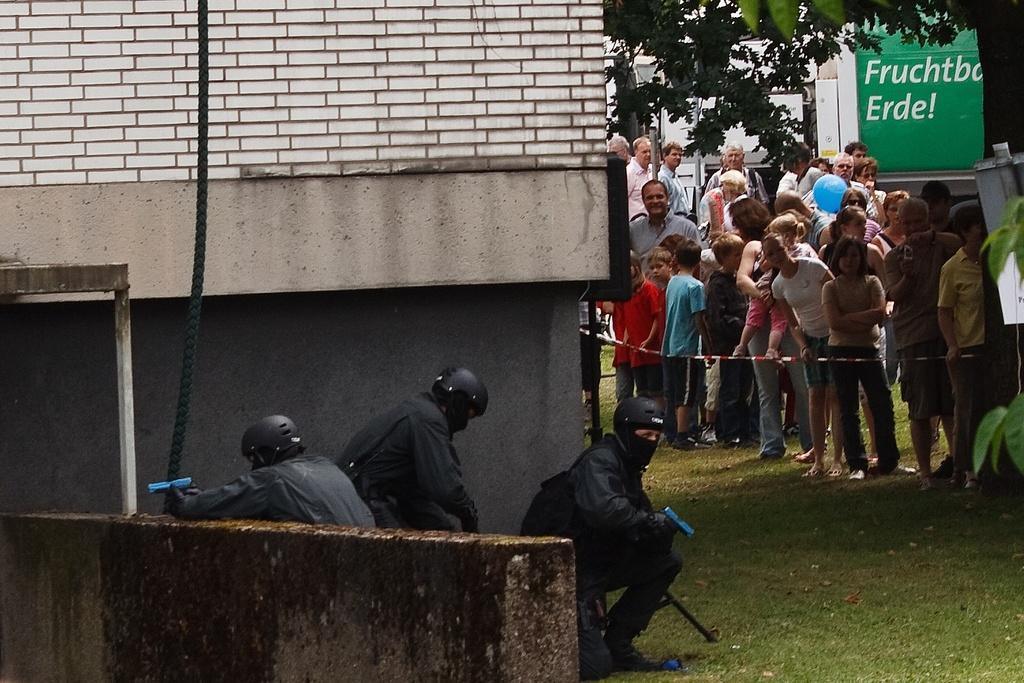Could you give a brief overview of what you see in this image? Here we can see three persons in squat position on the ground and they are holding guns in their hands and there is a wall,rope and a metal item. On the right there are few people,fence,tree,an object,a hoarding and some other items. 